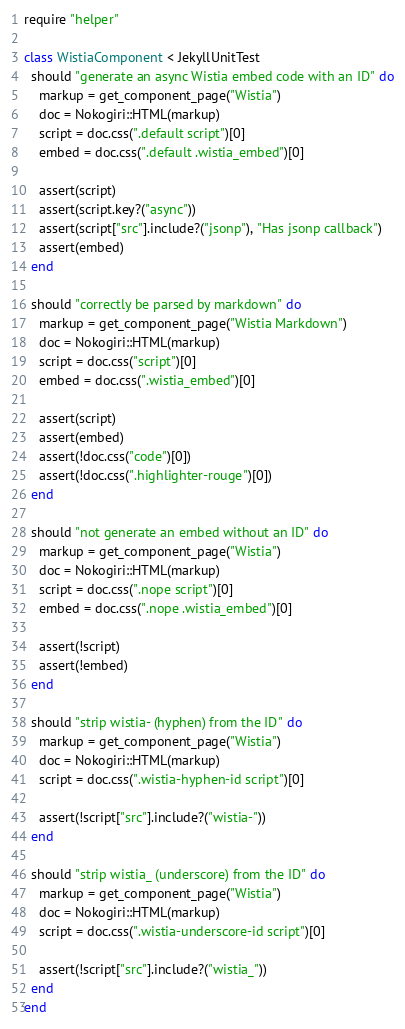<code> <loc_0><loc_0><loc_500><loc_500><_Ruby_>require "helper"

class WistiaComponent < JekyllUnitTest
  should "generate an async Wistia embed code with an ID" do
    markup = get_component_page("Wistia")
    doc = Nokogiri::HTML(markup)
    script = doc.css(".default script")[0]
    embed = doc.css(".default .wistia_embed")[0]

    assert(script)
    assert(script.key?("async"))
    assert(script["src"].include?("jsonp"), "Has jsonp callback")
    assert(embed)
  end

  should "correctly be parsed by markdown" do
    markup = get_component_page("Wistia Markdown")
    doc = Nokogiri::HTML(markup)
    script = doc.css("script")[0]
    embed = doc.css(".wistia_embed")[0]

    assert(script)
    assert(embed)
    assert(!doc.css("code")[0])
    assert(!doc.css(".highlighter-rouge")[0])
  end

  should "not generate an embed without an ID" do
    markup = get_component_page("Wistia")
    doc = Nokogiri::HTML(markup)
    script = doc.css(".nope script")[0]
    embed = doc.css(".nope .wistia_embed")[0]

    assert(!script)
    assert(!embed)
  end

  should "strip wistia- (hyphen) from the ID" do
    markup = get_component_page("Wistia")
    doc = Nokogiri::HTML(markup)
    script = doc.css(".wistia-hyphen-id script")[0]

    assert(!script["src"].include?("wistia-"))
  end

  should "strip wistia_ (underscore) from the ID" do
    markup = get_component_page("Wistia")
    doc = Nokogiri::HTML(markup)
    script = doc.css(".wistia-underscore-id script")[0]

    assert(!script["src"].include?("wistia_"))
  end
end
</code> 